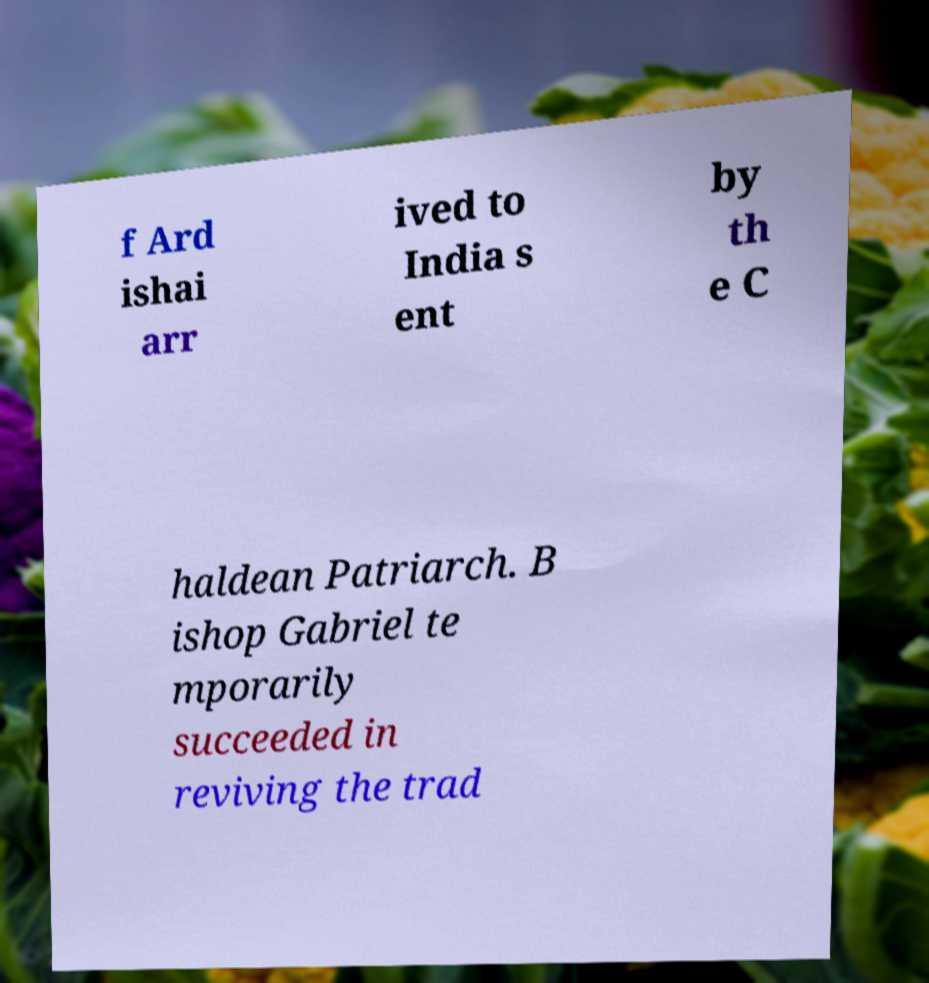Could you assist in decoding the text presented in this image and type it out clearly? f Ard ishai arr ived to India s ent by th e C haldean Patriarch. B ishop Gabriel te mporarily succeeded in reviving the trad 